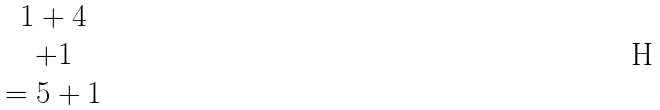Convert formula to latex. <formula><loc_0><loc_0><loc_500><loc_500>\begin{matrix} 1 + 4 \\ + 1 \\ = { 5 } + { 1 } \end{matrix}</formula> 